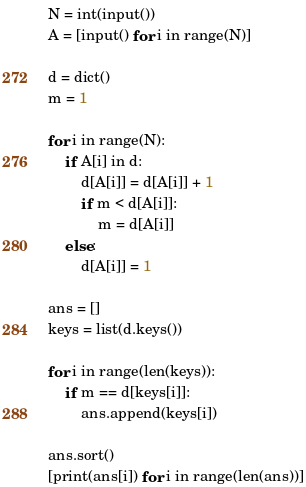Convert code to text. <code><loc_0><loc_0><loc_500><loc_500><_Python_>N = int(input())
A = [input() for i in range(N)]

d = dict()
m = 1

for i in range(N):
    if A[i] in d:
        d[A[i]] = d[A[i]] + 1
        if m < d[A[i]]:
            m = d[A[i]]
    else:
        d[A[i]] = 1

ans = []
keys = list(d.keys())

for i in range(len(keys)):
    if m == d[keys[i]]:
        ans.append(keys[i])

ans.sort()
[print(ans[i]) for i in range(len(ans))]</code> 